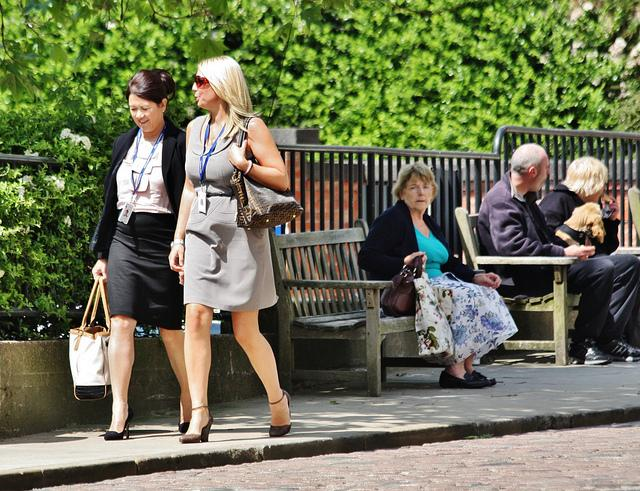Where are they likely to work from? Please explain your reasoning. office. The women are wearing office appropriate attire. 